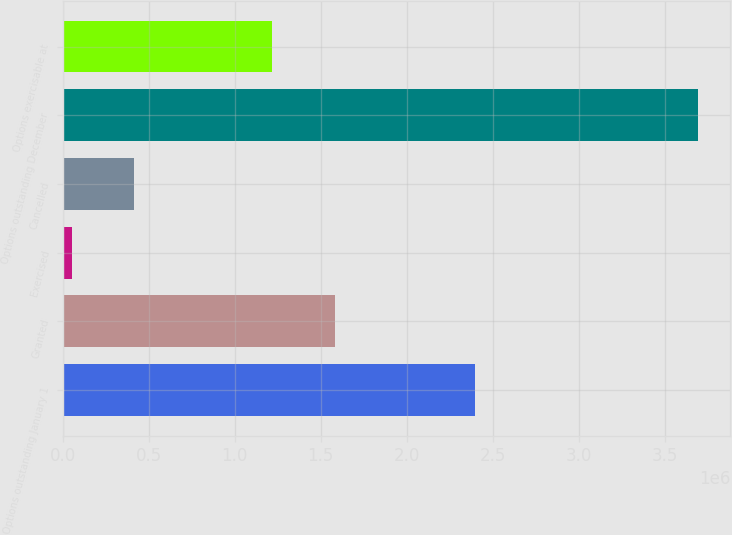<chart> <loc_0><loc_0><loc_500><loc_500><bar_chart><fcel>Options outstanding January 1<fcel>Granted<fcel>Exercised<fcel>Cancelled<fcel>Options outstanding December<fcel>Options exercisable at<nl><fcel>2.39733e+06<fcel>1.58136e+06<fcel>53164<fcel>417414<fcel>3.69567e+06<fcel>1.21711e+06<nl></chart> 